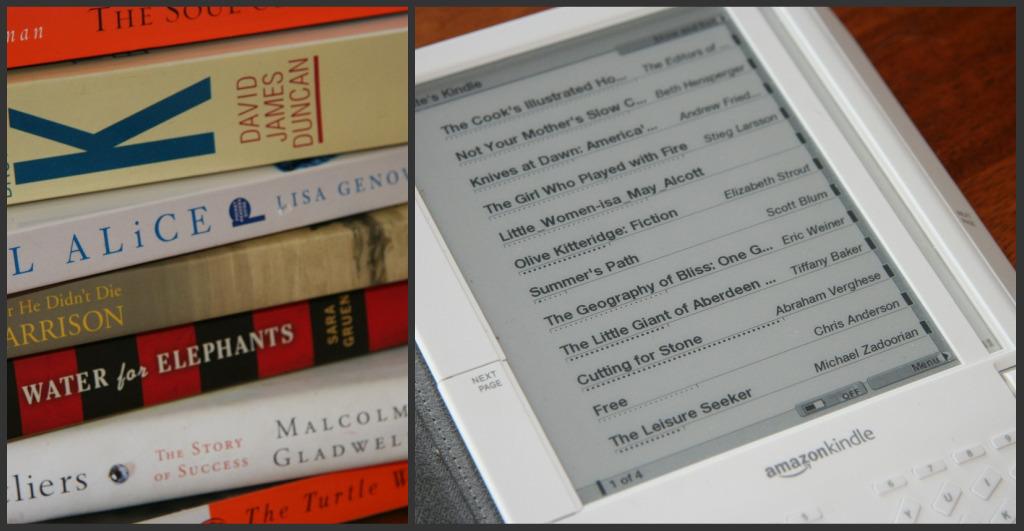What brand of electronic device is this?
Your response must be concise. Amazon kindle. 